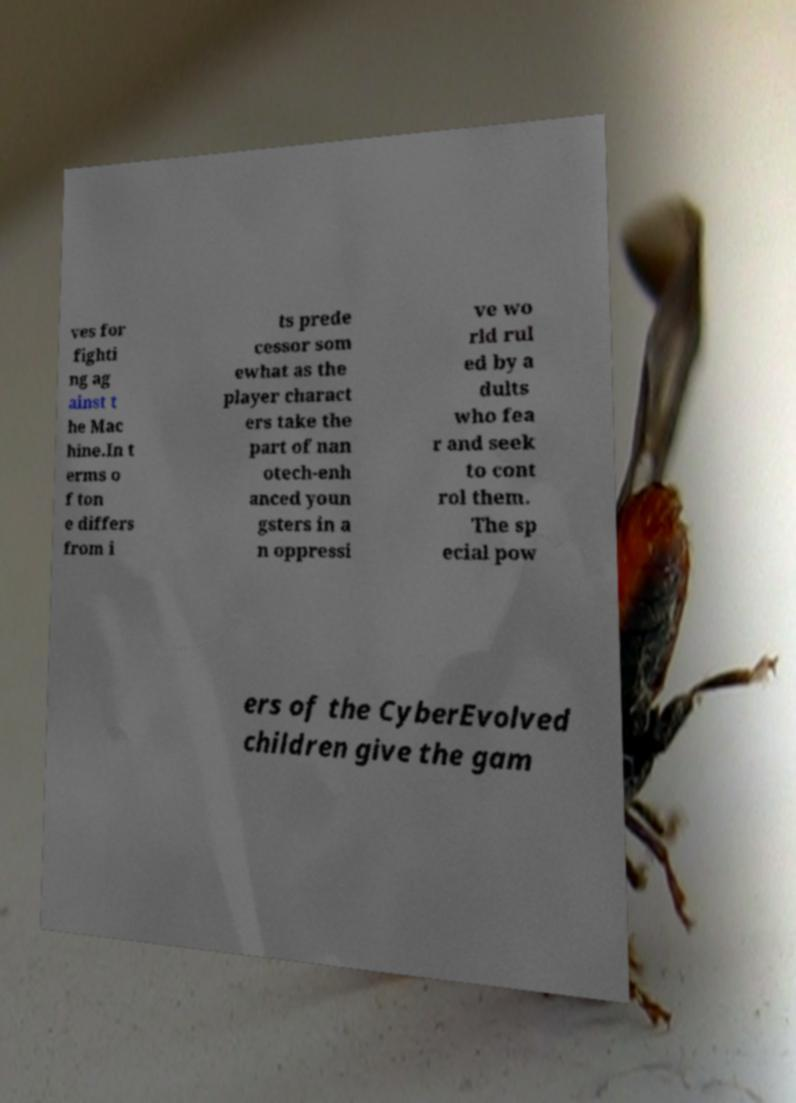I need the written content from this picture converted into text. Can you do that? ves for fighti ng ag ainst t he Mac hine.In t erms o f ton e differs from i ts prede cessor som ewhat as the player charact ers take the part of nan otech-enh anced youn gsters in a n oppressi ve wo rld rul ed by a dults who fea r and seek to cont rol them. The sp ecial pow ers of the CyberEvolved children give the gam 